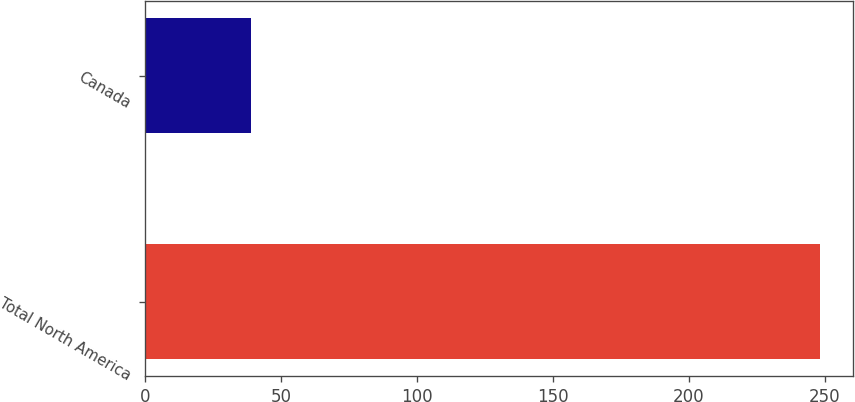Convert chart to OTSL. <chart><loc_0><loc_0><loc_500><loc_500><bar_chart><fcel>Total North America<fcel>Canada<nl><fcel>248<fcel>39<nl></chart> 